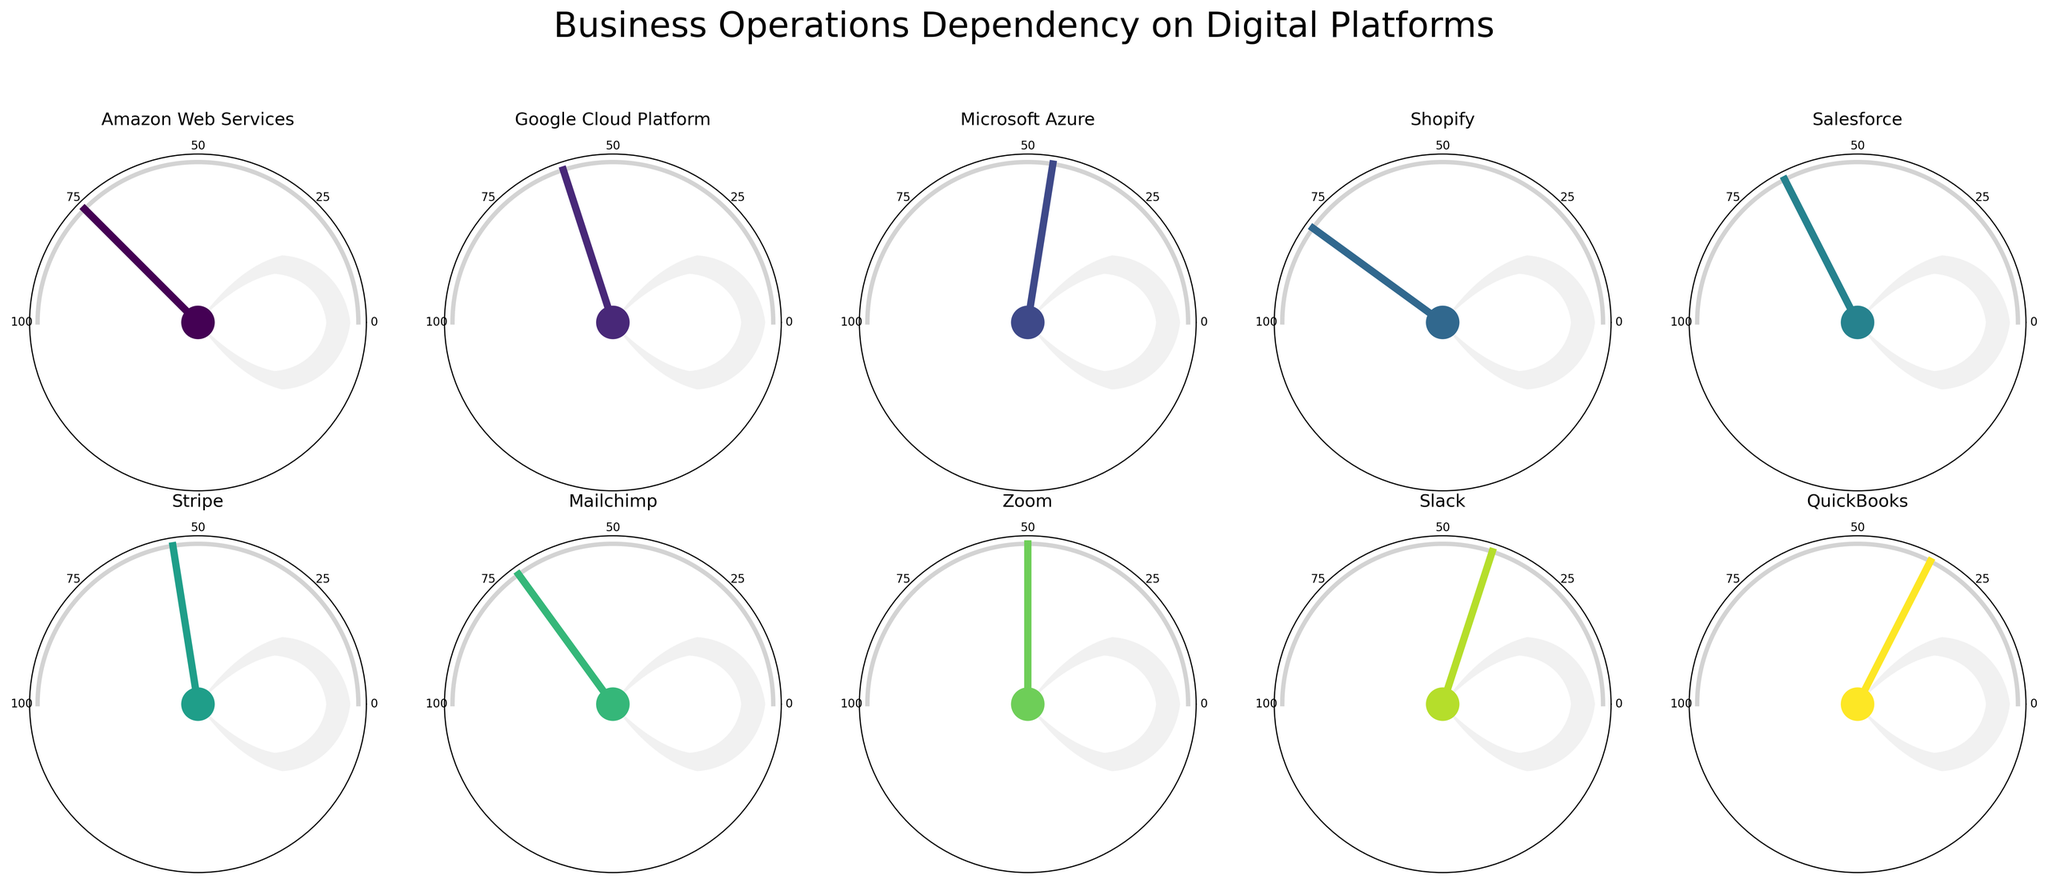How many categories are represented in the figure? The figure has 2 rows and 5 columns of subplots, each representing a different category, which totals to 10 categories.
Answer: 10 What is the title of the figure? The title is positioned above the subplots and clearly states the figure's main idea.
Answer: Business Operations Dependency on Digital Platforms Which digital platform shows the highest percentage of business operations dependency? By analyzing the gauge charts, the platform with the highest indicated value is Shopify.
Answer: Shopify What's the total combined percentage dependency of Amazon Web Services, Google Cloud Platform, and Microsoft Azure? Add the dependency percentages of the three platforms: 75% (Amazon Web Services) + 60% (Google Cloud Platform) + 45% (Microsoft Azure) = 180%.
Answer: 180% What is the average dependency percentage on the platforms Salesforce, Stripe, and Mailchimp? Calculate the average by adding the percentages of these platforms and then dividing by the number of platforms: (65 + 55 + 70) / 3 = 63.33% (rounded to two decimal places).
Answer: 63.33% Which two digital platforms are closest in their percentage dependency values? The gauge charts show that Zoom has 50% dependency and Stripe has 55% dependency, making them the closest in value with a 5 percentage point difference.
Answer: Zoom and Stripe Which platform has a lower dependency, Slack or QuickBooks? According to the gauge charts, Slack has a dependency of 40%, while QuickBooks has 35%, so QuickBooks has a lower dependency.
Answer: QuickBooks Identify the platforms with more than 60% dependency and list them. By viewing the gauge charts, the platforms with more than 60% dependency are Amazon Web Services, Google Cloud Platform, Shopify, Salesforce, and Mailchimp.
Answer: Amazon Web Services, Google Cloud Platform, Shopify, Salesforce, Mailchimp 